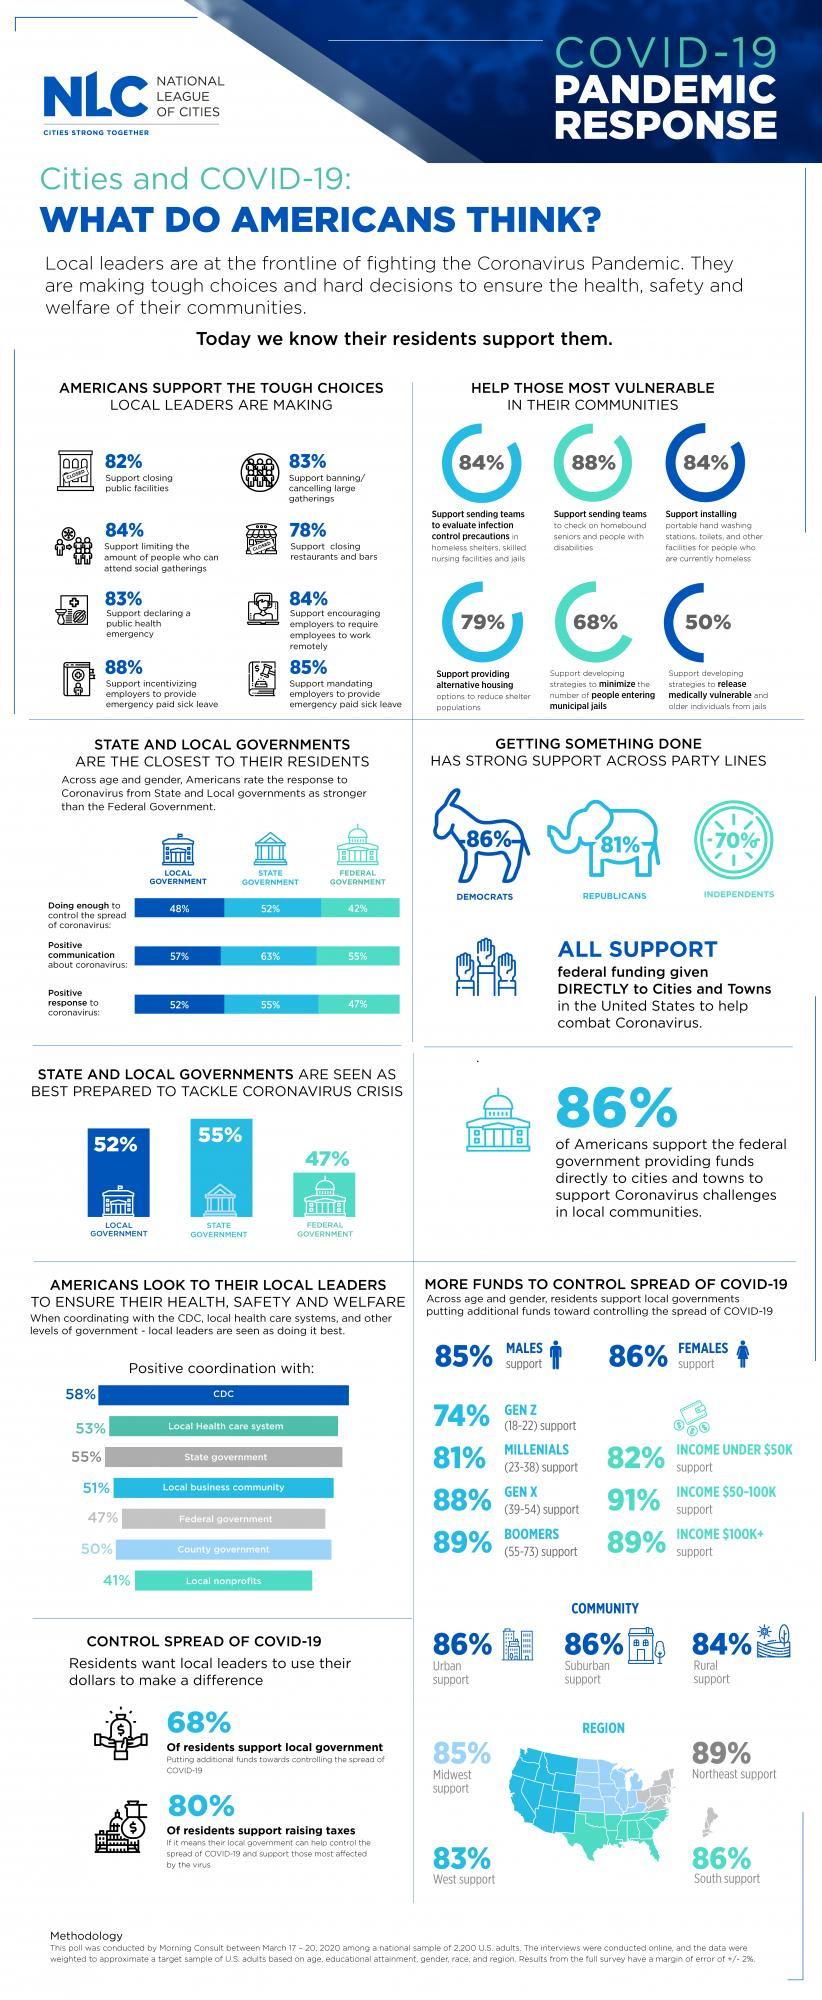Draw attention to some important aspects in this diagram. According to a recent survey, only 20% of residents support raising taxes. According to a recent survey, a majority of Americans, or 53%, believe that the federal government has not adequately responded to the coronavirus pandemic. The data shows that 18% of residents do not support closing public facilities. According to a recent survey, a significant portion of Generation Z, those born between 1997 and 2012, does not support increasing funds to control the spread of COVID-19. Specifically, 26% of respondents indicated that they do not support additional funding. According to a recent survey, only 22% of residents support the closure of restaurants and bars in the city. 